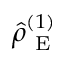<formula> <loc_0><loc_0><loc_500><loc_500>\hat { \rho } _ { E } ^ { ( 1 ) }</formula> 